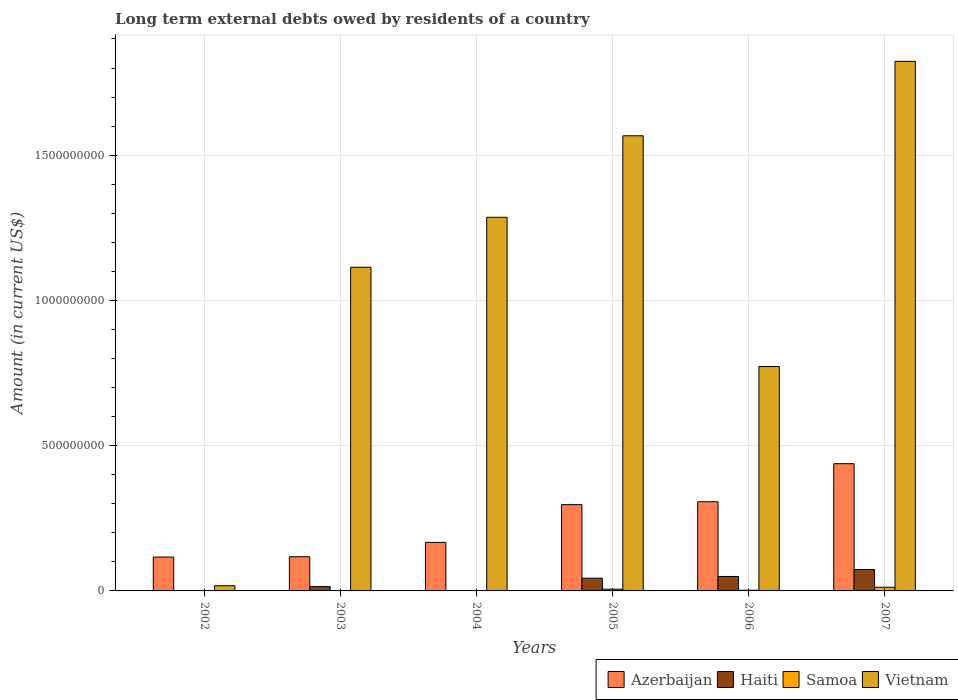How many groups of bars are there?
Provide a succinct answer. 6. Are the number of bars per tick equal to the number of legend labels?
Offer a very short reply. No. How many bars are there on the 6th tick from the right?
Your response must be concise. 2. In how many cases, is the number of bars for a given year not equal to the number of legend labels?
Provide a short and direct response. 2. What is the amount of long-term external debts owed by residents in Samoa in 2007?
Your answer should be compact. 1.26e+07. Across all years, what is the maximum amount of long-term external debts owed by residents in Haiti?
Ensure brevity in your answer.  7.37e+07. Across all years, what is the minimum amount of long-term external debts owed by residents in Azerbaijan?
Your answer should be very brief. 1.17e+08. In which year was the amount of long-term external debts owed by residents in Samoa maximum?
Your answer should be very brief. 2007. What is the total amount of long-term external debts owed by residents in Haiti in the graph?
Your answer should be compact. 1.82e+08. What is the difference between the amount of long-term external debts owed by residents in Samoa in 2003 and that in 2005?
Provide a succinct answer. -5.28e+06. What is the difference between the amount of long-term external debts owed by residents in Haiti in 2007 and the amount of long-term external debts owed by residents in Samoa in 2002?
Offer a terse response. 7.37e+07. What is the average amount of long-term external debts owed by residents in Azerbaijan per year?
Offer a terse response. 2.41e+08. In the year 2007, what is the difference between the amount of long-term external debts owed by residents in Azerbaijan and amount of long-term external debts owed by residents in Haiti?
Offer a terse response. 3.64e+08. What is the ratio of the amount of long-term external debts owed by residents in Azerbaijan in 2002 to that in 2006?
Offer a terse response. 0.38. What is the difference between the highest and the second highest amount of long-term external debts owed by residents in Haiti?
Your answer should be very brief. 2.40e+07. What is the difference between the highest and the lowest amount of long-term external debts owed by residents in Vietnam?
Provide a short and direct response. 1.81e+09. In how many years, is the amount of long-term external debts owed by residents in Vietnam greater than the average amount of long-term external debts owed by residents in Vietnam taken over all years?
Provide a succinct answer. 4. Does the graph contain any zero values?
Ensure brevity in your answer.  Yes. Does the graph contain grids?
Your response must be concise. Yes. How many legend labels are there?
Make the answer very short. 4. What is the title of the graph?
Make the answer very short. Long term external debts owed by residents of a country. What is the label or title of the Y-axis?
Your answer should be compact. Amount (in current US$). What is the Amount (in current US$) in Azerbaijan in 2002?
Provide a short and direct response. 1.17e+08. What is the Amount (in current US$) of Haiti in 2002?
Your answer should be very brief. 0. What is the Amount (in current US$) in Vietnam in 2002?
Your answer should be very brief. 1.79e+07. What is the Amount (in current US$) in Azerbaijan in 2003?
Give a very brief answer. 1.18e+08. What is the Amount (in current US$) of Haiti in 2003?
Offer a very short reply. 1.49e+07. What is the Amount (in current US$) in Samoa in 2003?
Keep it short and to the point. 8.21e+05. What is the Amount (in current US$) in Vietnam in 2003?
Your response must be concise. 1.11e+09. What is the Amount (in current US$) of Azerbaijan in 2004?
Your answer should be compact. 1.67e+08. What is the Amount (in current US$) in Haiti in 2004?
Keep it short and to the point. 0. What is the Amount (in current US$) in Samoa in 2004?
Offer a terse response. 6.79e+05. What is the Amount (in current US$) in Vietnam in 2004?
Give a very brief answer. 1.29e+09. What is the Amount (in current US$) in Azerbaijan in 2005?
Provide a short and direct response. 2.97e+08. What is the Amount (in current US$) in Haiti in 2005?
Offer a very short reply. 4.39e+07. What is the Amount (in current US$) of Samoa in 2005?
Give a very brief answer. 6.11e+06. What is the Amount (in current US$) in Vietnam in 2005?
Offer a very short reply. 1.57e+09. What is the Amount (in current US$) of Azerbaijan in 2006?
Your response must be concise. 3.07e+08. What is the Amount (in current US$) of Haiti in 2006?
Keep it short and to the point. 4.97e+07. What is the Amount (in current US$) in Samoa in 2006?
Provide a short and direct response. 2.40e+06. What is the Amount (in current US$) of Vietnam in 2006?
Make the answer very short. 7.72e+08. What is the Amount (in current US$) of Azerbaijan in 2007?
Your answer should be very brief. 4.38e+08. What is the Amount (in current US$) in Haiti in 2007?
Ensure brevity in your answer.  7.37e+07. What is the Amount (in current US$) of Samoa in 2007?
Provide a succinct answer. 1.26e+07. What is the Amount (in current US$) of Vietnam in 2007?
Offer a very short reply. 1.82e+09. Across all years, what is the maximum Amount (in current US$) of Azerbaijan?
Offer a terse response. 4.38e+08. Across all years, what is the maximum Amount (in current US$) of Haiti?
Your response must be concise. 7.37e+07. Across all years, what is the maximum Amount (in current US$) in Samoa?
Provide a short and direct response. 1.26e+07. Across all years, what is the maximum Amount (in current US$) of Vietnam?
Your answer should be very brief. 1.82e+09. Across all years, what is the minimum Amount (in current US$) of Azerbaijan?
Give a very brief answer. 1.17e+08. Across all years, what is the minimum Amount (in current US$) in Samoa?
Make the answer very short. 0. Across all years, what is the minimum Amount (in current US$) in Vietnam?
Offer a terse response. 1.79e+07. What is the total Amount (in current US$) of Azerbaijan in the graph?
Your response must be concise. 1.44e+09. What is the total Amount (in current US$) of Haiti in the graph?
Your response must be concise. 1.82e+08. What is the total Amount (in current US$) of Samoa in the graph?
Give a very brief answer. 2.26e+07. What is the total Amount (in current US$) in Vietnam in the graph?
Your answer should be very brief. 6.58e+09. What is the difference between the Amount (in current US$) in Azerbaijan in 2002 and that in 2003?
Keep it short and to the point. -1.11e+06. What is the difference between the Amount (in current US$) of Vietnam in 2002 and that in 2003?
Provide a succinct answer. -1.10e+09. What is the difference between the Amount (in current US$) of Azerbaijan in 2002 and that in 2004?
Provide a short and direct response. -5.05e+07. What is the difference between the Amount (in current US$) of Vietnam in 2002 and that in 2004?
Your response must be concise. -1.27e+09. What is the difference between the Amount (in current US$) in Azerbaijan in 2002 and that in 2005?
Ensure brevity in your answer.  -1.80e+08. What is the difference between the Amount (in current US$) in Vietnam in 2002 and that in 2005?
Provide a succinct answer. -1.55e+09. What is the difference between the Amount (in current US$) in Azerbaijan in 2002 and that in 2006?
Ensure brevity in your answer.  -1.90e+08. What is the difference between the Amount (in current US$) in Vietnam in 2002 and that in 2006?
Offer a very short reply. -7.54e+08. What is the difference between the Amount (in current US$) in Azerbaijan in 2002 and that in 2007?
Ensure brevity in your answer.  -3.21e+08. What is the difference between the Amount (in current US$) in Vietnam in 2002 and that in 2007?
Ensure brevity in your answer.  -1.81e+09. What is the difference between the Amount (in current US$) of Azerbaijan in 2003 and that in 2004?
Keep it short and to the point. -4.94e+07. What is the difference between the Amount (in current US$) of Samoa in 2003 and that in 2004?
Ensure brevity in your answer.  1.42e+05. What is the difference between the Amount (in current US$) of Vietnam in 2003 and that in 2004?
Your answer should be very brief. -1.72e+08. What is the difference between the Amount (in current US$) in Azerbaijan in 2003 and that in 2005?
Ensure brevity in your answer.  -1.79e+08. What is the difference between the Amount (in current US$) of Haiti in 2003 and that in 2005?
Keep it short and to the point. -2.90e+07. What is the difference between the Amount (in current US$) of Samoa in 2003 and that in 2005?
Provide a short and direct response. -5.28e+06. What is the difference between the Amount (in current US$) of Vietnam in 2003 and that in 2005?
Ensure brevity in your answer.  -4.53e+08. What is the difference between the Amount (in current US$) in Azerbaijan in 2003 and that in 2006?
Keep it short and to the point. -1.89e+08. What is the difference between the Amount (in current US$) in Haiti in 2003 and that in 2006?
Ensure brevity in your answer.  -3.48e+07. What is the difference between the Amount (in current US$) of Samoa in 2003 and that in 2006?
Keep it short and to the point. -1.58e+06. What is the difference between the Amount (in current US$) of Vietnam in 2003 and that in 2006?
Provide a short and direct response. 3.42e+08. What is the difference between the Amount (in current US$) of Azerbaijan in 2003 and that in 2007?
Give a very brief answer. -3.20e+08. What is the difference between the Amount (in current US$) of Haiti in 2003 and that in 2007?
Provide a succinct answer. -5.88e+07. What is the difference between the Amount (in current US$) in Samoa in 2003 and that in 2007?
Your answer should be very brief. -1.18e+07. What is the difference between the Amount (in current US$) of Vietnam in 2003 and that in 2007?
Your answer should be very brief. -7.09e+08. What is the difference between the Amount (in current US$) of Azerbaijan in 2004 and that in 2005?
Your answer should be very brief. -1.30e+08. What is the difference between the Amount (in current US$) of Samoa in 2004 and that in 2005?
Make the answer very short. -5.43e+06. What is the difference between the Amount (in current US$) in Vietnam in 2004 and that in 2005?
Offer a terse response. -2.81e+08. What is the difference between the Amount (in current US$) in Azerbaijan in 2004 and that in 2006?
Provide a short and direct response. -1.40e+08. What is the difference between the Amount (in current US$) of Samoa in 2004 and that in 2006?
Make the answer very short. -1.72e+06. What is the difference between the Amount (in current US$) of Vietnam in 2004 and that in 2006?
Your response must be concise. 5.14e+08. What is the difference between the Amount (in current US$) of Azerbaijan in 2004 and that in 2007?
Provide a succinct answer. -2.71e+08. What is the difference between the Amount (in current US$) of Samoa in 2004 and that in 2007?
Your answer should be compact. -1.19e+07. What is the difference between the Amount (in current US$) in Vietnam in 2004 and that in 2007?
Offer a very short reply. -5.37e+08. What is the difference between the Amount (in current US$) of Azerbaijan in 2005 and that in 2006?
Offer a terse response. -1.00e+07. What is the difference between the Amount (in current US$) of Haiti in 2005 and that in 2006?
Ensure brevity in your answer.  -5.85e+06. What is the difference between the Amount (in current US$) in Samoa in 2005 and that in 2006?
Provide a short and direct response. 3.71e+06. What is the difference between the Amount (in current US$) in Vietnam in 2005 and that in 2006?
Provide a succinct answer. 7.94e+08. What is the difference between the Amount (in current US$) of Azerbaijan in 2005 and that in 2007?
Offer a terse response. -1.41e+08. What is the difference between the Amount (in current US$) in Haiti in 2005 and that in 2007?
Ensure brevity in your answer.  -2.98e+07. What is the difference between the Amount (in current US$) in Samoa in 2005 and that in 2007?
Your answer should be very brief. -6.47e+06. What is the difference between the Amount (in current US$) of Vietnam in 2005 and that in 2007?
Your answer should be very brief. -2.56e+08. What is the difference between the Amount (in current US$) in Azerbaijan in 2006 and that in 2007?
Your answer should be very brief. -1.31e+08. What is the difference between the Amount (in current US$) in Haiti in 2006 and that in 2007?
Ensure brevity in your answer.  -2.40e+07. What is the difference between the Amount (in current US$) of Samoa in 2006 and that in 2007?
Provide a short and direct response. -1.02e+07. What is the difference between the Amount (in current US$) of Vietnam in 2006 and that in 2007?
Make the answer very short. -1.05e+09. What is the difference between the Amount (in current US$) of Azerbaijan in 2002 and the Amount (in current US$) of Haiti in 2003?
Ensure brevity in your answer.  1.02e+08. What is the difference between the Amount (in current US$) of Azerbaijan in 2002 and the Amount (in current US$) of Samoa in 2003?
Offer a terse response. 1.16e+08. What is the difference between the Amount (in current US$) in Azerbaijan in 2002 and the Amount (in current US$) in Vietnam in 2003?
Offer a terse response. -9.98e+08. What is the difference between the Amount (in current US$) of Azerbaijan in 2002 and the Amount (in current US$) of Samoa in 2004?
Your response must be concise. 1.16e+08. What is the difference between the Amount (in current US$) of Azerbaijan in 2002 and the Amount (in current US$) of Vietnam in 2004?
Ensure brevity in your answer.  -1.17e+09. What is the difference between the Amount (in current US$) in Azerbaijan in 2002 and the Amount (in current US$) in Haiti in 2005?
Give a very brief answer. 7.27e+07. What is the difference between the Amount (in current US$) of Azerbaijan in 2002 and the Amount (in current US$) of Samoa in 2005?
Offer a very short reply. 1.10e+08. What is the difference between the Amount (in current US$) in Azerbaijan in 2002 and the Amount (in current US$) in Vietnam in 2005?
Your answer should be compact. -1.45e+09. What is the difference between the Amount (in current US$) in Azerbaijan in 2002 and the Amount (in current US$) in Haiti in 2006?
Give a very brief answer. 6.69e+07. What is the difference between the Amount (in current US$) in Azerbaijan in 2002 and the Amount (in current US$) in Samoa in 2006?
Provide a succinct answer. 1.14e+08. What is the difference between the Amount (in current US$) of Azerbaijan in 2002 and the Amount (in current US$) of Vietnam in 2006?
Offer a very short reply. -6.56e+08. What is the difference between the Amount (in current US$) in Azerbaijan in 2002 and the Amount (in current US$) in Haiti in 2007?
Your answer should be very brief. 4.29e+07. What is the difference between the Amount (in current US$) of Azerbaijan in 2002 and the Amount (in current US$) of Samoa in 2007?
Keep it short and to the point. 1.04e+08. What is the difference between the Amount (in current US$) in Azerbaijan in 2002 and the Amount (in current US$) in Vietnam in 2007?
Your answer should be compact. -1.71e+09. What is the difference between the Amount (in current US$) of Azerbaijan in 2003 and the Amount (in current US$) of Samoa in 2004?
Your response must be concise. 1.17e+08. What is the difference between the Amount (in current US$) of Azerbaijan in 2003 and the Amount (in current US$) of Vietnam in 2004?
Offer a terse response. -1.17e+09. What is the difference between the Amount (in current US$) in Haiti in 2003 and the Amount (in current US$) in Samoa in 2004?
Offer a terse response. 1.42e+07. What is the difference between the Amount (in current US$) in Haiti in 2003 and the Amount (in current US$) in Vietnam in 2004?
Keep it short and to the point. -1.27e+09. What is the difference between the Amount (in current US$) of Samoa in 2003 and the Amount (in current US$) of Vietnam in 2004?
Keep it short and to the point. -1.29e+09. What is the difference between the Amount (in current US$) in Azerbaijan in 2003 and the Amount (in current US$) in Haiti in 2005?
Your response must be concise. 7.38e+07. What is the difference between the Amount (in current US$) in Azerbaijan in 2003 and the Amount (in current US$) in Samoa in 2005?
Offer a very short reply. 1.12e+08. What is the difference between the Amount (in current US$) in Azerbaijan in 2003 and the Amount (in current US$) in Vietnam in 2005?
Offer a terse response. -1.45e+09. What is the difference between the Amount (in current US$) of Haiti in 2003 and the Amount (in current US$) of Samoa in 2005?
Your response must be concise. 8.80e+06. What is the difference between the Amount (in current US$) in Haiti in 2003 and the Amount (in current US$) in Vietnam in 2005?
Your response must be concise. -1.55e+09. What is the difference between the Amount (in current US$) of Samoa in 2003 and the Amount (in current US$) of Vietnam in 2005?
Your answer should be compact. -1.57e+09. What is the difference between the Amount (in current US$) of Azerbaijan in 2003 and the Amount (in current US$) of Haiti in 2006?
Offer a very short reply. 6.80e+07. What is the difference between the Amount (in current US$) in Azerbaijan in 2003 and the Amount (in current US$) in Samoa in 2006?
Offer a terse response. 1.15e+08. What is the difference between the Amount (in current US$) of Azerbaijan in 2003 and the Amount (in current US$) of Vietnam in 2006?
Make the answer very short. -6.55e+08. What is the difference between the Amount (in current US$) in Haiti in 2003 and the Amount (in current US$) in Samoa in 2006?
Keep it short and to the point. 1.25e+07. What is the difference between the Amount (in current US$) of Haiti in 2003 and the Amount (in current US$) of Vietnam in 2006?
Your answer should be very brief. -7.57e+08. What is the difference between the Amount (in current US$) of Samoa in 2003 and the Amount (in current US$) of Vietnam in 2006?
Your answer should be compact. -7.72e+08. What is the difference between the Amount (in current US$) of Azerbaijan in 2003 and the Amount (in current US$) of Haiti in 2007?
Provide a succinct answer. 4.40e+07. What is the difference between the Amount (in current US$) of Azerbaijan in 2003 and the Amount (in current US$) of Samoa in 2007?
Make the answer very short. 1.05e+08. What is the difference between the Amount (in current US$) of Azerbaijan in 2003 and the Amount (in current US$) of Vietnam in 2007?
Provide a short and direct response. -1.71e+09. What is the difference between the Amount (in current US$) in Haiti in 2003 and the Amount (in current US$) in Samoa in 2007?
Provide a short and direct response. 2.33e+06. What is the difference between the Amount (in current US$) of Haiti in 2003 and the Amount (in current US$) of Vietnam in 2007?
Offer a very short reply. -1.81e+09. What is the difference between the Amount (in current US$) of Samoa in 2003 and the Amount (in current US$) of Vietnam in 2007?
Provide a succinct answer. -1.82e+09. What is the difference between the Amount (in current US$) of Azerbaijan in 2004 and the Amount (in current US$) of Haiti in 2005?
Offer a very short reply. 1.23e+08. What is the difference between the Amount (in current US$) in Azerbaijan in 2004 and the Amount (in current US$) in Samoa in 2005?
Provide a succinct answer. 1.61e+08. What is the difference between the Amount (in current US$) of Azerbaijan in 2004 and the Amount (in current US$) of Vietnam in 2005?
Ensure brevity in your answer.  -1.40e+09. What is the difference between the Amount (in current US$) of Samoa in 2004 and the Amount (in current US$) of Vietnam in 2005?
Keep it short and to the point. -1.57e+09. What is the difference between the Amount (in current US$) in Azerbaijan in 2004 and the Amount (in current US$) in Haiti in 2006?
Provide a short and direct response. 1.17e+08. What is the difference between the Amount (in current US$) in Azerbaijan in 2004 and the Amount (in current US$) in Samoa in 2006?
Ensure brevity in your answer.  1.65e+08. What is the difference between the Amount (in current US$) in Azerbaijan in 2004 and the Amount (in current US$) in Vietnam in 2006?
Offer a terse response. -6.05e+08. What is the difference between the Amount (in current US$) in Samoa in 2004 and the Amount (in current US$) in Vietnam in 2006?
Provide a succinct answer. -7.72e+08. What is the difference between the Amount (in current US$) in Azerbaijan in 2004 and the Amount (in current US$) in Haiti in 2007?
Offer a very short reply. 9.34e+07. What is the difference between the Amount (in current US$) in Azerbaijan in 2004 and the Amount (in current US$) in Samoa in 2007?
Provide a succinct answer. 1.55e+08. What is the difference between the Amount (in current US$) in Azerbaijan in 2004 and the Amount (in current US$) in Vietnam in 2007?
Your response must be concise. -1.66e+09. What is the difference between the Amount (in current US$) in Samoa in 2004 and the Amount (in current US$) in Vietnam in 2007?
Provide a short and direct response. -1.82e+09. What is the difference between the Amount (in current US$) in Azerbaijan in 2005 and the Amount (in current US$) in Haiti in 2006?
Your answer should be very brief. 2.47e+08. What is the difference between the Amount (in current US$) of Azerbaijan in 2005 and the Amount (in current US$) of Samoa in 2006?
Your answer should be very brief. 2.95e+08. What is the difference between the Amount (in current US$) in Azerbaijan in 2005 and the Amount (in current US$) in Vietnam in 2006?
Provide a succinct answer. -4.75e+08. What is the difference between the Amount (in current US$) in Haiti in 2005 and the Amount (in current US$) in Samoa in 2006?
Your response must be concise. 4.15e+07. What is the difference between the Amount (in current US$) in Haiti in 2005 and the Amount (in current US$) in Vietnam in 2006?
Give a very brief answer. -7.29e+08. What is the difference between the Amount (in current US$) of Samoa in 2005 and the Amount (in current US$) of Vietnam in 2006?
Give a very brief answer. -7.66e+08. What is the difference between the Amount (in current US$) of Azerbaijan in 2005 and the Amount (in current US$) of Haiti in 2007?
Your answer should be very brief. 2.23e+08. What is the difference between the Amount (in current US$) of Azerbaijan in 2005 and the Amount (in current US$) of Samoa in 2007?
Your answer should be compact. 2.84e+08. What is the difference between the Amount (in current US$) of Azerbaijan in 2005 and the Amount (in current US$) of Vietnam in 2007?
Provide a short and direct response. -1.53e+09. What is the difference between the Amount (in current US$) of Haiti in 2005 and the Amount (in current US$) of Samoa in 2007?
Offer a terse response. 3.13e+07. What is the difference between the Amount (in current US$) in Haiti in 2005 and the Amount (in current US$) in Vietnam in 2007?
Ensure brevity in your answer.  -1.78e+09. What is the difference between the Amount (in current US$) of Samoa in 2005 and the Amount (in current US$) of Vietnam in 2007?
Ensure brevity in your answer.  -1.82e+09. What is the difference between the Amount (in current US$) of Azerbaijan in 2006 and the Amount (in current US$) of Haiti in 2007?
Ensure brevity in your answer.  2.33e+08. What is the difference between the Amount (in current US$) in Azerbaijan in 2006 and the Amount (in current US$) in Samoa in 2007?
Provide a short and direct response. 2.94e+08. What is the difference between the Amount (in current US$) in Azerbaijan in 2006 and the Amount (in current US$) in Vietnam in 2007?
Give a very brief answer. -1.52e+09. What is the difference between the Amount (in current US$) in Haiti in 2006 and the Amount (in current US$) in Samoa in 2007?
Your response must be concise. 3.71e+07. What is the difference between the Amount (in current US$) in Haiti in 2006 and the Amount (in current US$) in Vietnam in 2007?
Provide a succinct answer. -1.77e+09. What is the difference between the Amount (in current US$) in Samoa in 2006 and the Amount (in current US$) in Vietnam in 2007?
Offer a very short reply. -1.82e+09. What is the average Amount (in current US$) of Azerbaijan per year?
Make the answer very short. 2.41e+08. What is the average Amount (in current US$) of Haiti per year?
Make the answer very short. 3.04e+07. What is the average Amount (in current US$) in Samoa per year?
Give a very brief answer. 3.76e+06. What is the average Amount (in current US$) of Vietnam per year?
Provide a short and direct response. 1.10e+09. In the year 2002, what is the difference between the Amount (in current US$) in Azerbaijan and Amount (in current US$) in Vietnam?
Keep it short and to the point. 9.87e+07. In the year 2003, what is the difference between the Amount (in current US$) of Azerbaijan and Amount (in current US$) of Haiti?
Give a very brief answer. 1.03e+08. In the year 2003, what is the difference between the Amount (in current US$) of Azerbaijan and Amount (in current US$) of Samoa?
Provide a succinct answer. 1.17e+08. In the year 2003, what is the difference between the Amount (in current US$) of Azerbaijan and Amount (in current US$) of Vietnam?
Keep it short and to the point. -9.97e+08. In the year 2003, what is the difference between the Amount (in current US$) in Haiti and Amount (in current US$) in Samoa?
Your answer should be compact. 1.41e+07. In the year 2003, what is the difference between the Amount (in current US$) in Haiti and Amount (in current US$) in Vietnam?
Give a very brief answer. -1.10e+09. In the year 2003, what is the difference between the Amount (in current US$) in Samoa and Amount (in current US$) in Vietnam?
Your answer should be very brief. -1.11e+09. In the year 2004, what is the difference between the Amount (in current US$) of Azerbaijan and Amount (in current US$) of Samoa?
Your answer should be compact. 1.66e+08. In the year 2004, what is the difference between the Amount (in current US$) of Azerbaijan and Amount (in current US$) of Vietnam?
Make the answer very short. -1.12e+09. In the year 2004, what is the difference between the Amount (in current US$) in Samoa and Amount (in current US$) in Vietnam?
Ensure brevity in your answer.  -1.29e+09. In the year 2005, what is the difference between the Amount (in current US$) of Azerbaijan and Amount (in current US$) of Haiti?
Your answer should be compact. 2.53e+08. In the year 2005, what is the difference between the Amount (in current US$) in Azerbaijan and Amount (in current US$) in Samoa?
Keep it short and to the point. 2.91e+08. In the year 2005, what is the difference between the Amount (in current US$) in Azerbaijan and Amount (in current US$) in Vietnam?
Offer a terse response. -1.27e+09. In the year 2005, what is the difference between the Amount (in current US$) of Haiti and Amount (in current US$) of Samoa?
Ensure brevity in your answer.  3.78e+07. In the year 2005, what is the difference between the Amount (in current US$) in Haiti and Amount (in current US$) in Vietnam?
Your response must be concise. -1.52e+09. In the year 2005, what is the difference between the Amount (in current US$) in Samoa and Amount (in current US$) in Vietnam?
Give a very brief answer. -1.56e+09. In the year 2006, what is the difference between the Amount (in current US$) of Azerbaijan and Amount (in current US$) of Haiti?
Offer a terse response. 2.57e+08. In the year 2006, what is the difference between the Amount (in current US$) in Azerbaijan and Amount (in current US$) in Samoa?
Keep it short and to the point. 3.05e+08. In the year 2006, what is the difference between the Amount (in current US$) in Azerbaijan and Amount (in current US$) in Vietnam?
Give a very brief answer. -4.65e+08. In the year 2006, what is the difference between the Amount (in current US$) in Haiti and Amount (in current US$) in Samoa?
Your answer should be very brief. 4.73e+07. In the year 2006, what is the difference between the Amount (in current US$) of Haiti and Amount (in current US$) of Vietnam?
Your answer should be compact. -7.23e+08. In the year 2006, what is the difference between the Amount (in current US$) in Samoa and Amount (in current US$) in Vietnam?
Provide a succinct answer. -7.70e+08. In the year 2007, what is the difference between the Amount (in current US$) of Azerbaijan and Amount (in current US$) of Haiti?
Your answer should be compact. 3.64e+08. In the year 2007, what is the difference between the Amount (in current US$) in Azerbaijan and Amount (in current US$) in Samoa?
Offer a very short reply. 4.25e+08. In the year 2007, what is the difference between the Amount (in current US$) of Azerbaijan and Amount (in current US$) of Vietnam?
Ensure brevity in your answer.  -1.38e+09. In the year 2007, what is the difference between the Amount (in current US$) in Haiti and Amount (in current US$) in Samoa?
Your answer should be compact. 6.11e+07. In the year 2007, what is the difference between the Amount (in current US$) of Haiti and Amount (in current US$) of Vietnam?
Provide a short and direct response. -1.75e+09. In the year 2007, what is the difference between the Amount (in current US$) of Samoa and Amount (in current US$) of Vietnam?
Give a very brief answer. -1.81e+09. What is the ratio of the Amount (in current US$) of Azerbaijan in 2002 to that in 2003?
Your answer should be very brief. 0.99. What is the ratio of the Amount (in current US$) in Vietnam in 2002 to that in 2003?
Your answer should be compact. 0.02. What is the ratio of the Amount (in current US$) in Azerbaijan in 2002 to that in 2004?
Provide a succinct answer. 0.7. What is the ratio of the Amount (in current US$) in Vietnam in 2002 to that in 2004?
Your answer should be very brief. 0.01. What is the ratio of the Amount (in current US$) of Azerbaijan in 2002 to that in 2005?
Your answer should be very brief. 0.39. What is the ratio of the Amount (in current US$) of Vietnam in 2002 to that in 2005?
Your answer should be very brief. 0.01. What is the ratio of the Amount (in current US$) of Azerbaijan in 2002 to that in 2006?
Give a very brief answer. 0.38. What is the ratio of the Amount (in current US$) in Vietnam in 2002 to that in 2006?
Give a very brief answer. 0.02. What is the ratio of the Amount (in current US$) in Azerbaijan in 2002 to that in 2007?
Make the answer very short. 0.27. What is the ratio of the Amount (in current US$) of Vietnam in 2002 to that in 2007?
Offer a very short reply. 0.01. What is the ratio of the Amount (in current US$) in Azerbaijan in 2003 to that in 2004?
Your response must be concise. 0.7. What is the ratio of the Amount (in current US$) in Samoa in 2003 to that in 2004?
Offer a very short reply. 1.21. What is the ratio of the Amount (in current US$) in Vietnam in 2003 to that in 2004?
Give a very brief answer. 0.87. What is the ratio of the Amount (in current US$) of Azerbaijan in 2003 to that in 2005?
Offer a terse response. 0.4. What is the ratio of the Amount (in current US$) in Haiti in 2003 to that in 2005?
Make the answer very short. 0.34. What is the ratio of the Amount (in current US$) in Samoa in 2003 to that in 2005?
Your answer should be very brief. 0.13. What is the ratio of the Amount (in current US$) in Vietnam in 2003 to that in 2005?
Ensure brevity in your answer.  0.71. What is the ratio of the Amount (in current US$) in Azerbaijan in 2003 to that in 2006?
Ensure brevity in your answer.  0.38. What is the ratio of the Amount (in current US$) in Haiti in 2003 to that in 2006?
Your answer should be compact. 0.3. What is the ratio of the Amount (in current US$) in Samoa in 2003 to that in 2006?
Your response must be concise. 0.34. What is the ratio of the Amount (in current US$) in Vietnam in 2003 to that in 2006?
Your answer should be compact. 1.44. What is the ratio of the Amount (in current US$) in Azerbaijan in 2003 to that in 2007?
Give a very brief answer. 0.27. What is the ratio of the Amount (in current US$) in Haiti in 2003 to that in 2007?
Give a very brief answer. 0.2. What is the ratio of the Amount (in current US$) in Samoa in 2003 to that in 2007?
Make the answer very short. 0.07. What is the ratio of the Amount (in current US$) of Vietnam in 2003 to that in 2007?
Offer a terse response. 0.61. What is the ratio of the Amount (in current US$) of Azerbaijan in 2004 to that in 2005?
Make the answer very short. 0.56. What is the ratio of the Amount (in current US$) in Samoa in 2004 to that in 2005?
Your answer should be very brief. 0.11. What is the ratio of the Amount (in current US$) of Vietnam in 2004 to that in 2005?
Offer a terse response. 0.82. What is the ratio of the Amount (in current US$) in Azerbaijan in 2004 to that in 2006?
Provide a succinct answer. 0.54. What is the ratio of the Amount (in current US$) in Samoa in 2004 to that in 2006?
Provide a short and direct response. 0.28. What is the ratio of the Amount (in current US$) in Vietnam in 2004 to that in 2006?
Keep it short and to the point. 1.67. What is the ratio of the Amount (in current US$) of Azerbaijan in 2004 to that in 2007?
Provide a succinct answer. 0.38. What is the ratio of the Amount (in current US$) in Samoa in 2004 to that in 2007?
Your answer should be compact. 0.05. What is the ratio of the Amount (in current US$) of Vietnam in 2004 to that in 2007?
Make the answer very short. 0.71. What is the ratio of the Amount (in current US$) of Azerbaijan in 2005 to that in 2006?
Your answer should be compact. 0.97. What is the ratio of the Amount (in current US$) of Haiti in 2005 to that in 2006?
Your answer should be very brief. 0.88. What is the ratio of the Amount (in current US$) in Samoa in 2005 to that in 2006?
Offer a very short reply. 2.55. What is the ratio of the Amount (in current US$) of Vietnam in 2005 to that in 2006?
Your answer should be very brief. 2.03. What is the ratio of the Amount (in current US$) of Azerbaijan in 2005 to that in 2007?
Offer a very short reply. 0.68. What is the ratio of the Amount (in current US$) of Haiti in 2005 to that in 2007?
Provide a succinct answer. 0.6. What is the ratio of the Amount (in current US$) of Samoa in 2005 to that in 2007?
Offer a very short reply. 0.49. What is the ratio of the Amount (in current US$) of Vietnam in 2005 to that in 2007?
Provide a short and direct response. 0.86. What is the ratio of the Amount (in current US$) of Azerbaijan in 2006 to that in 2007?
Your response must be concise. 0.7. What is the ratio of the Amount (in current US$) in Haiti in 2006 to that in 2007?
Provide a short and direct response. 0.67. What is the ratio of the Amount (in current US$) of Samoa in 2006 to that in 2007?
Your answer should be very brief. 0.19. What is the ratio of the Amount (in current US$) of Vietnam in 2006 to that in 2007?
Provide a succinct answer. 0.42. What is the difference between the highest and the second highest Amount (in current US$) of Azerbaijan?
Keep it short and to the point. 1.31e+08. What is the difference between the highest and the second highest Amount (in current US$) in Haiti?
Keep it short and to the point. 2.40e+07. What is the difference between the highest and the second highest Amount (in current US$) of Samoa?
Offer a terse response. 6.47e+06. What is the difference between the highest and the second highest Amount (in current US$) in Vietnam?
Ensure brevity in your answer.  2.56e+08. What is the difference between the highest and the lowest Amount (in current US$) of Azerbaijan?
Provide a short and direct response. 3.21e+08. What is the difference between the highest and the lowest Amount (in current US$) in Haiti?
Give a very brief answer. 7.37e+07. What is the difference between the highest and the lowest Amount (in current US$) of Samoa?
Offer a terse response. 1.26e+07. What is the difference between the highest and the lowest Amount (in current US$) of Vietnam?
Provide a succinct answer. 1.81e+09. 